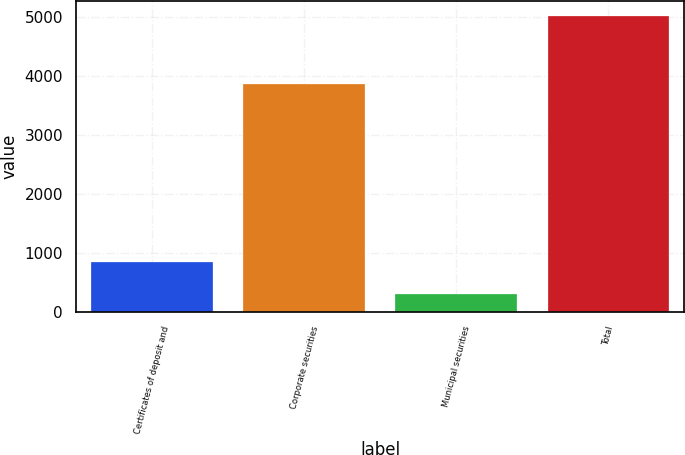Convert chart to OTSL. <chart><loc_0><loc_0><loc_500><loc_500><bar_chart><fcel>Certificates of deposit and<fcel>Corporate securities<fcel>Municipal securities<fcel>Total<nl><fcel>856<fcel>3854<fcel>298<fcel>5008<nl></chart> 